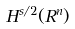Convert formula to latex. <formula><loc_0><loc_0><loc_500><loc_500>H ^ { s / 2 } ( R ^ { n } )</formula> 